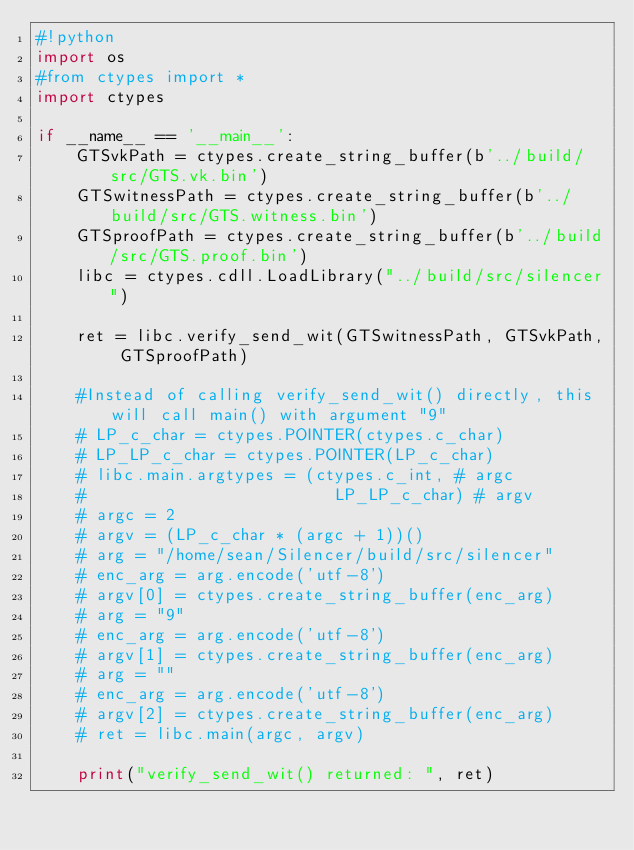<code> <loc_0><loc_0><loc_500><loc_500><_Python_>#!python
import os
#from ctypes import *
import ctypes

if __name__ == '__main__':
    GTSvkPath = ctypes.create_string_buffer(b'../build/src/GTS.vk.bin')
    GTSwitnessPath = ctypes.create_string_buffer(b'../build/src/GTS.witness.bin')
    GTSproofPath = ctypes.create_string_buffer(b'../build/src/GTS.proof.bin')
    libc = ctypes.cdll.LoadLibrary("../build/src/silencer")

    ret = libc.verify_send_wit(GTSwitnessPath, GTSvkPath, GTSproofPath)

    #Instead of calling verify_send_wit() directly, this will call main() with argument "9"
    # LP_c_char = ctypes.POINTER(ctypes.c_char)
    # LP_LP_c_char = ctypes.POINTER(LP_c_char)
    # libc.main.argtypes = (ctypes.c_int, # argc
    #                         LP_LP_c_char) # argv
    # argc = 2
    # argv = (LP_c_char * (argc + 1))()
    # arg = "/home/sean/Silencer/build/src/silencer"
    # enc_arg = arg.encode('utf-8')
    # argv[0] = ctypes.create_string_buffer(enc_arg)
    # arg = "9"
    # enc_arg = arg.encode('utf-8')
    # argv[1] = ctypes.create_string_buffer(enc_arg)
    # arg = ""
    # enc_arg = arg.encode('utf-8')
    # argv[2] = ctypes.create_string_buffer(enc_arg)
    # ret = libc.main(argc, argv)

    print("verify_send_wit() returned: ", ret)
</code> 